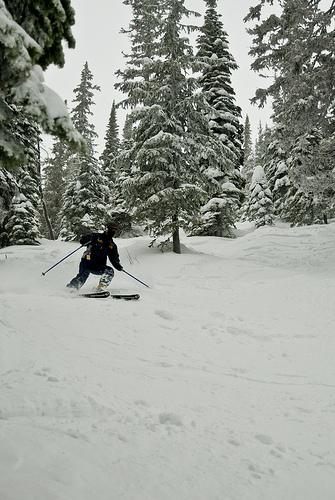Question: what color are the trees?
Choices:
A. Red.
B. Brown.
C. Orange.
D. Green.
Answer with the letter. Answer: D Question: how does the weather look?
Choices:
A. Very hot.
B. Rainy.
C. Nippy.
D. Very cold.
Answer with the letter. Answer: D Question: what is the man on?
Choices:
A. Skateboard.
B. Skis.
C. Surf board.
D. Treadmill.
Answer with the letter. Answer: B 